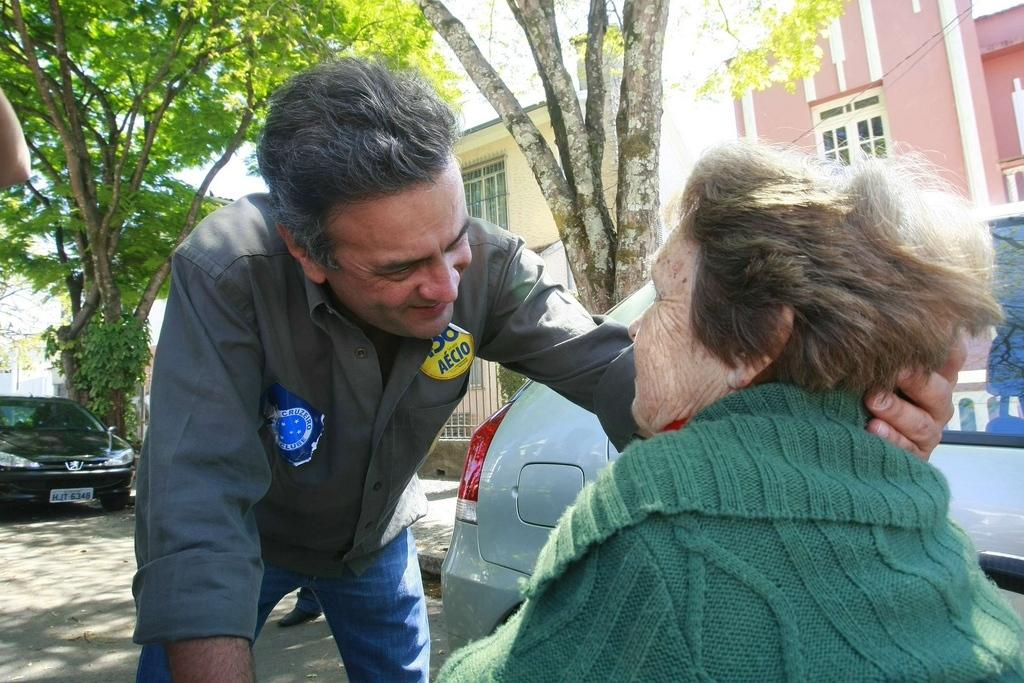How many people are in the image? There are two people in the image. What are the people doing in the image? The people are on a path. What else can be seen on the path? There are vehicles on the path. What can be seen in the background of the image? There is a tree and buildings visible in the background. What type of hammer is being used by the person in the image? There is no hammer present in the image. What is the purpose of the bell in the image? There is no bell present in the image. 